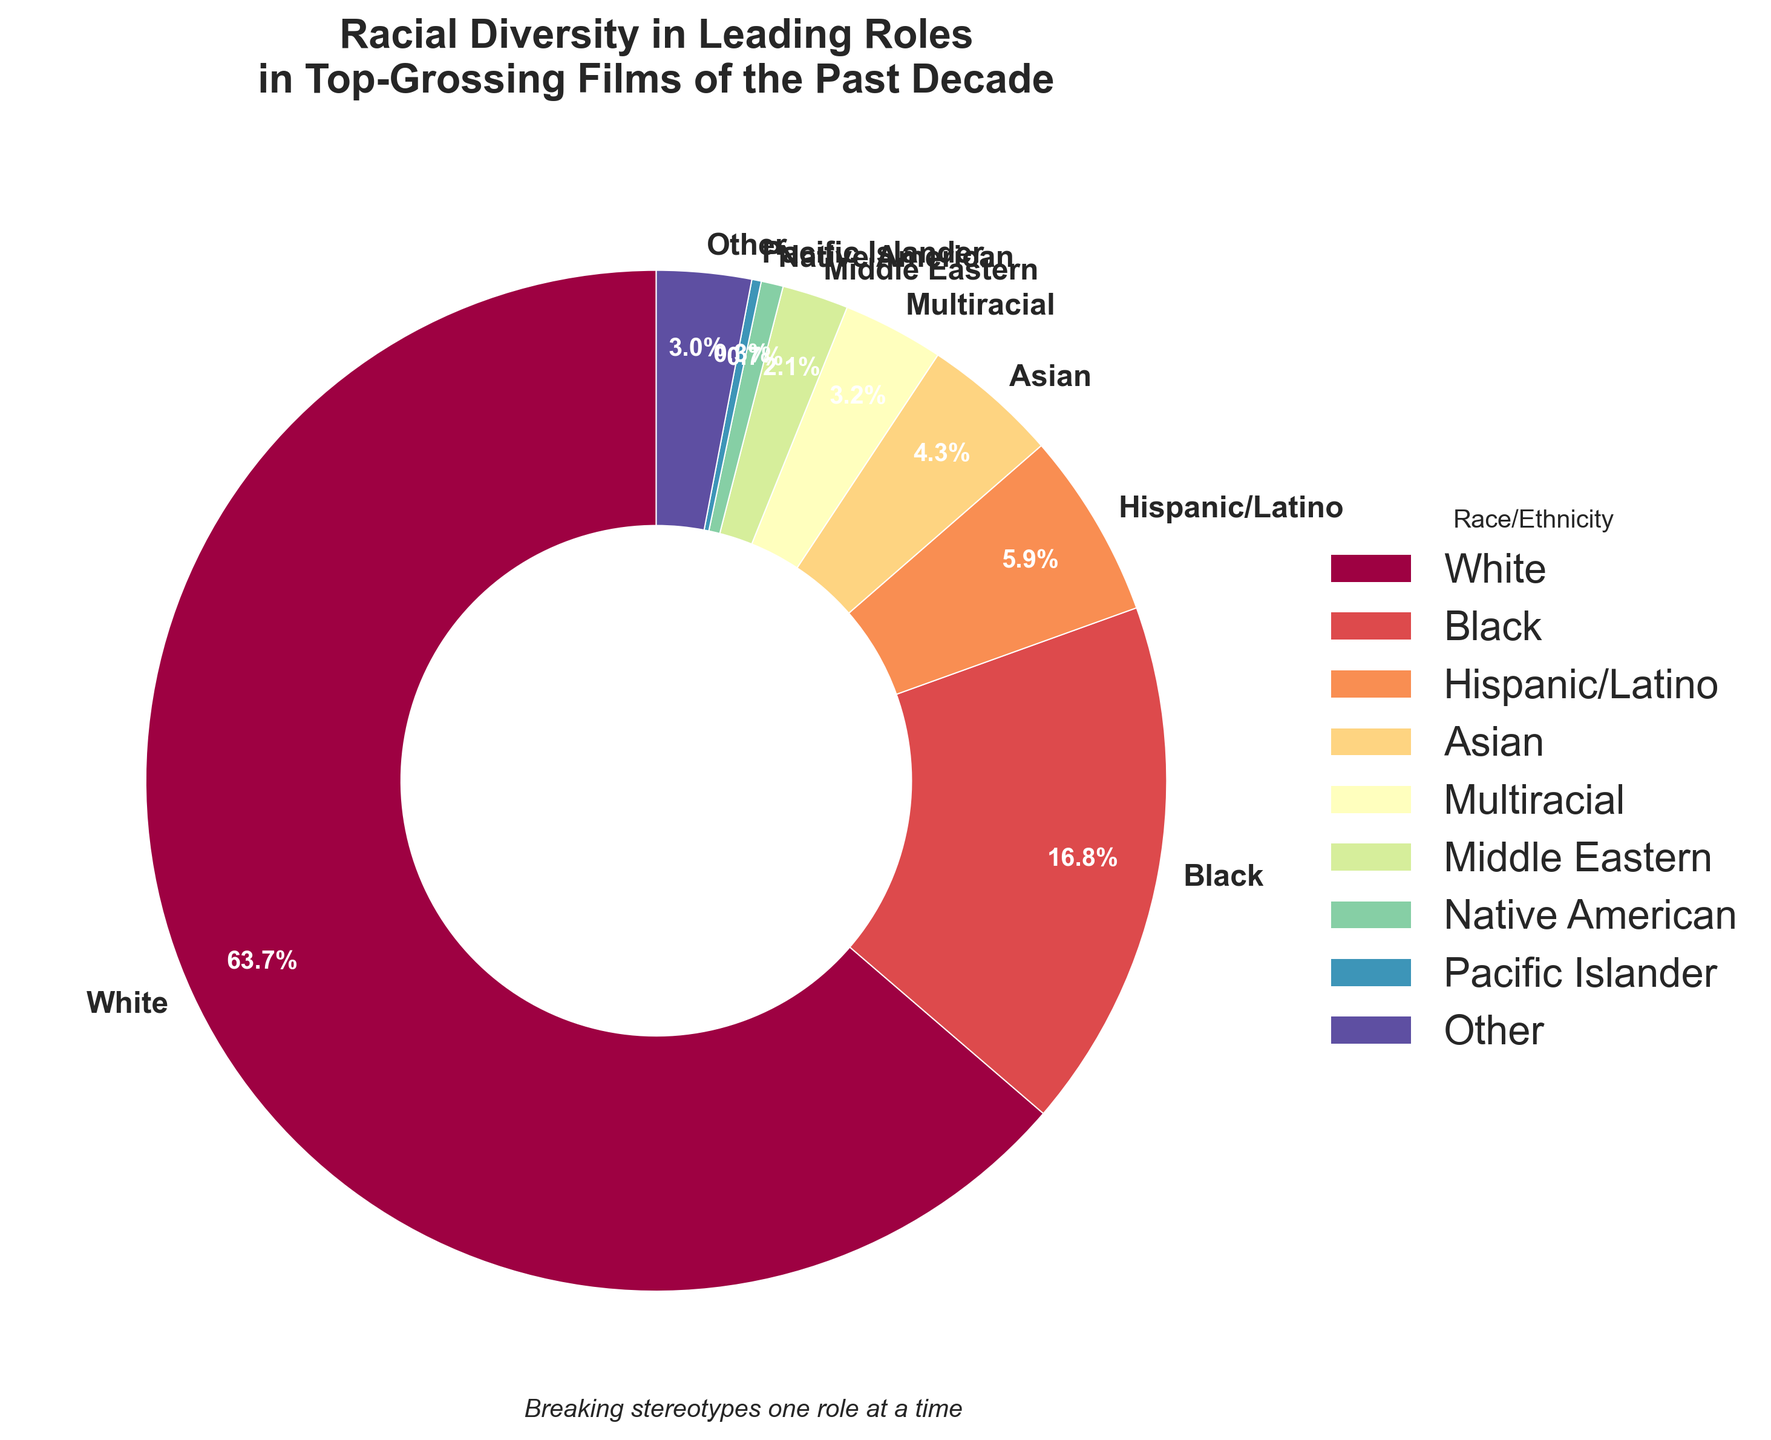Which racial group has the highest percentage of leading roles? The pie chart shows the percentages of leading roles by racial group. By observing the slices and their labels, we can see that the group with the highest percentage is "White" at 63.7%.
Answer: White What is the combined percentage of leading roles held by Hispanic/Latino and Asian actors? To find the combined percentage, add the percentages for Hispanic/Latino (5.9%) and Asian (4.3%). Thus, 5.9% + 4.3% = 10.2%.
Answer: 10.2% Which racial group has a significantly lower percentage of leading roles compared to Black actors? By comparing the percentages of each group against Black actors (16.8%), we find that Native American actors (0.7%) have a significantly lower percentage.
Answer: Native American Is the percentage of Multiracial leading roles greater than the combined total of Middle Eastern and Pacific Islander leading roles? To determine this, compare the percentage for Multiracial (3.2%) with the combined percentages of Middle Eastern (2.1%) and Pacific Islander (0.3%), summing to 2.4%. Since 3.2% > 2.4%, the answer is yes.
Answer: Yes How does the percentage of Black leading roles compare to that of Other racial groups? The percentage of Black leading roles is 16.8% and that for Other is 3.0%. Since 16.8% is greater than 3.0%, Black has a higher percentage.
Answer: Black has greater percentage What is the total percentage of leading roles held by racial groups other than White? To find the total percentage of non-White roles, sum the percentages of all other groups: 16.8% (Black) + 5.9% (Hispanic/Latino) + 4.3% (Asian) + 3.2% (Multiracial) + 2.1% (Middle Eastern) + 0.7% (Native American) + 0.3% (Pacific Islander) + 3.0% (Other) = 36.3%.
Answer: 36.3% What is the smallest racial group in terms of leading roles? By examining each slice of the pie chart and the corresponding percentages, we see the smallest group is Pacific Islander with 0.3%.
Answer: Pacific Islander How many racial groups have a percentage of leading roles below 5%? By reviewing the chart, we see the groups with percentages below 5% are Asian (4.3%), Multiracial (3.2%), Middle Eastern (2.1%), Native American (0.7%), Pacific Islander (0.3%), and Other (3.0%). There are 6 such groups.
Answer: 6 What is the difference in percentage between the largest and smallest racial groups? The largest group is White (63.7%) and the smallest is Pacific Islander (0.3%). The difference is calculated as 63.7% - 0.3% = 63.4%.
Answer: 63.4% Which racial group has the closest percentage of leading roles to 5%, and what is that percentage? The chart shows that Hispanic/Latino has a percentage of 5.9%, which is the closest to 5%.
Answer: Hispanic/Latino has 5.9% 